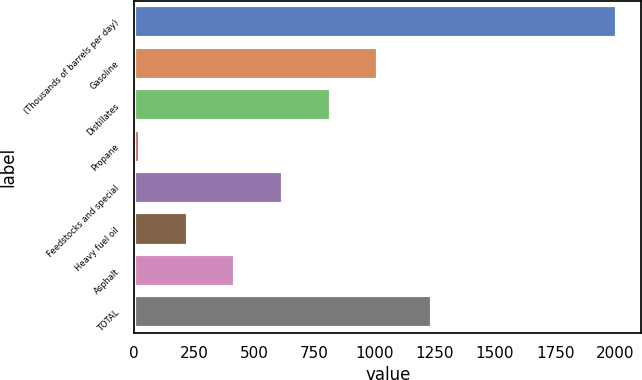<chart> <loc_0><loc_0><loc_500><loc_500><bar_chart><fcel>(Thousands of barrels per day)<fcel>Gasoline<fcel>Distillates<fcel>Propane<fcel>Feedstocks and special<fcel>Heavy fuel oil<fcel>Asphalt<fcel>TOTAL<nl><fcel>2007<fcel>1015<fcel>816.6<fcel>23<fcel>618.2<fcel>221.4<fcel>419.8<fcel>1239<nl></chart> 